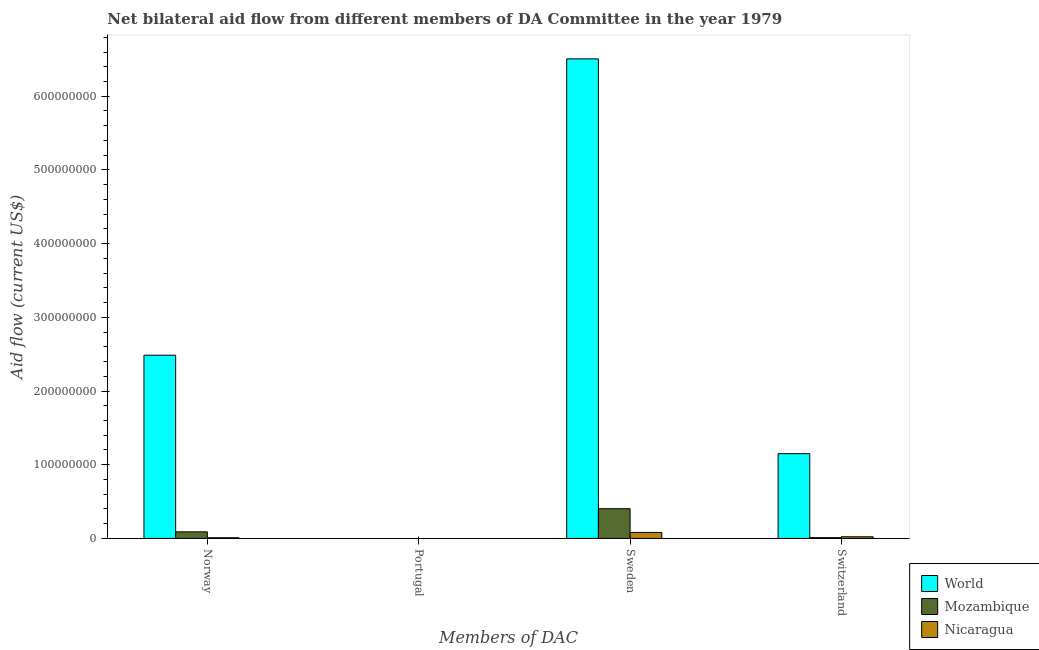How many bars are there on the 3rd tick from the right?
Give a very brief answer. 0. What is the label of the 2nd group of bars from the left?
Offer a very short reply. Portugal. What is the amount of aid given by norway in Nicaragua?
Your answer should be very brief. 9.30e+05. Across all countries, what is the maximum amount of aid given by sweden?
Your answer should be compact. 6.51e+08. Across all countries, what is the minimum amount of aid given by norway?
Offer a terse response. 9.30e+05. What is the total amount of aid given by norway in the graph?
Ensure brevity in your answer.  2.59e+08. What is the difference between the amount of aid given by sweden in World and that in Nicaragua?
Give a very brief answer. 6.43e+08. What is the difference between the amount of aid given by sweden in World and the amount of aid given by norway in Mozambique?
Make the answer very short. 6.42e+08. What is the average amount of aid given by switzerland per country?
Your answer should be compact. 3.95e+07. What is the difference between the amount of aid given by norway and amount of aid given by switzerland in Nicaragua?
Your answer should be compact. -1.34e+06. What is the ratio of the amount of aid given by sweden in Mozambique to that in Nicaragua?
Ensure brevity in your answer.  4.97. Is the difference between the amount of aid given by norway in World and Mozambique greater than the difference between the amount of aid given by sweden in World and Mozambique?
Provide a short and direct response. No. What is the difference between the highest and the second highest amount of aid given by norway?
Offer a terse response. 2.40e+08. What is the difference between the highest and the lowest amount of aid given by sweden?
Offer a terse response. 6.43e+08. In how many countries, is the amount of aid given by sweden greater than the average amount of aid given by sweden taken over all countries?
Your response must be concise. 1. Is it the case that in every country, the sum of the amount of aid given by portugal and amount of aid given by norway is greater than the sum of amount of aid given by switzerland and amount of aid given by sweden?
Ensure brevity in your answer.  No. Is it the case that in every country, the sum of the amount of aid given by norway and amount of aid given by portugal is greater than the amount of aid given by sweden?
Give a very brief answer. No. Are all the bars in the graph horizontal?
Offer a terse response. No. Does the graph contain any zero values?
Your response must be concise. Yes. Where does the legend appear in the graph?
Your response must be concise. Bottom right. What is the title of the graph?
Your answer should be very brief. Net bilateral aid flow from different members of DA Committee in the year 1979. Does "Pakistan" appear as one of the legend labels in the graph?
Offer a very short reply. No. What is the label or title of the X-axis?
Give a very brief answer. Members of DAC. What is the label or title of the Y-axis?
Your answer should be very brief. Aid flow (current US$). What is the Aid flow (current US$) of World in Norway?
Keep it short and to the point. 2.49e+08. What is the Aid flow (current US$) of Mozambique in Norway?
Your response must be concise. 8.96e+06. What is the Aid flow (current US$) in Nicaragua in Norway?
Offer a terse response. 9.30e+05. What is the Aid flow (current US$) in World in Portugal?
Your response must be concise. Nan. What is the Aid flow (current US$) in Mozambique in Portugal?
Provide a short and direct response. Nan. What is the Aid flow (current US$) in Nicaragua in Portugal?
Provide a short and direct response. Nan. What is the Aid flow (current US$) of World in Sweden?
Make the answer very short. 6.51e+08. What is the Aid flow (current US$) of Mozambique in Sweden?
Offer a very short reply. 4.03e+07. What is the Aid flow (current US$) of Nicaragua in Sweden?
Give a very brief answer. 8.12e+06. What is the Aid flow (current US$) of World in Switzerland?
Your response must be concise. 1.15e+08. What is the Aid flow (current US$) of Mozambique in Switzerland?
Your answer should be very brief. 1.09e+06. What is the Aid flow (current US$) of Nicaragua in Switzerland?
Your response must be concise. 2.27e+06. Across all Members of DAC, what is the maximum Aid flow (current US$) of World?
Make the answer very short. 6.51e+08. Across all Members of DAC, what is the maximum Aid flow (current US$) in Mozambique?
Provide a succinct answer. 4.03e+07. Across all Members of DAC, what is the maximum Aid flow (current US$) of Nicaragua?
Give a very brief answer. 8.12e+06. Across all Members of DAC, what is the minimum Aid flow (current US$) in World?
Your response must be concise. 1.15e+08. Across all Members of DAC, what is the minimum Aid flow (current US$) of Mozambique?
Your answer should be very brief. 1.09e+06. Across all Members of DAC, what is the minimum Aid flow (current US$) in Nicaragua?
Your answer should be compact. 9.30e+05. What is the total Aid flow (current US$) in World in the graph?
Provide a succinct answer. 1.01e+09. What is the total Aid flow (current US$) of Mozambique in the graph?
Offer a terse response. 5.04e+07. What is the total Aid flow (current US$) of Nicaragua in the graph?
Offer a very short reply. 1.13e+07. What is the difference between the Aid flow (current US$) in World in Norway and that in Portugal?
Provide a short and direct response. Nan. What is the difference between the Aid flow (current US$) in Mozambique in Norway and that in Portugal?
Provide a succinct answer. Nan. What is the difference between the Aid flow (current US$) in Nicaragua in Norway and that in Portugal?
Your answer should be very brief. Nan. What is the difference between the Aid flow (current US$) of World in Norway and that in Sweden?
Offer a very short reply. -4.02e+08. What is the difference between the Aid flow (current US$) in Mozambique in Norway and that in Sweden?
Keep it short and to the point. -3.14e+07. What is the difference between the Aid flow (current US$) of Nicaragua in Norway and that in Sweden?
Keep it short and to the point. -7.19e+06. What is the difference between the Aid flow (current US$) in World in Norway and that in Switzerland?
Offer a very short reply. 1.34e+08. What is the difference between the Aid flow (current US$) in Mozambique in Norway and that in Switzerland?
Provide a succinct answer. 7.87e+06. What is the difference between the Aid flow (current US$) of Nicaragua in Norway and that in Switzerland?
Your answer should be very brief. -1.34e+06. What is the difference between the Aid flow (current US$) of World in Portugal and that in Sweden?
Your response must be concise. Nan. What is the difference between the Aid flow (current US$) of Mozambique in Portugal and that in Sweden?
Keep it short and to the point. Nan. What is the difference between the Aid flow (current US$) of Nicaragua in Portugal and that in Sweden?
Offer a very short reply. Nan. What is the difference between the Aid flow (current US$) of World in Portugal and that in Switzerland?
Give a very brief answer. Nan. What is the difference between the Aid flow (current US$) in Mozambique in Portugal and that in Switzerland?
Make the answer very short. Nan. What is the difference between the Aid flow (current US$) of Nicaragua in Portugal and that in Switzerland?
Give a very brief answer. Nan. What is the difference between the Aid flow (current US$) in World in Sweden and that in Switzerland?
Your answer should be very brief. 5.36e+08. What is the difference between the Aid flow (current US$) of Mozambique in Sweden and that in Switzerland?
Provide a short and direct response. 3.92e+07. What is the difference between the Aid flow (current US$) in Nicaragua in Sweden and that in Switzerland?
Provide a succinct answer. 5.85e+06. What is the difference between the Aid flow (current US$) of World in Norway and the Aid flow (current US$) of Mozambique in Portugal?
Offer a very short reply. Nan. What is the difference between the Aid flow (current US$) in World in Norway and the Aid flow (current US$) in Nicaragua in Portugal?
Offer a very short reply. Nan. What is the difference between the Aid flow (current US$) of Mozambique in Norway and the Aid flow (current US$) of Nicaragua in Portugal?
Your answer should be very brief. Nan. What is the difference between the Aid flow (current US$) in World in Norway and the Aid flow (current US$) in Mozambique in Sweden?
Keep it short and to the point. 2.08e+08. What is the difference between the Aid flow (current US$) of World in Norway and the Aid flow (current US$) of Nicaragua in Sweden?
Offer a terse response. 2.41e+08. What is the difference between the Aid flow (current US$) in Mozambique in Norway and the Aid flow (current US$) in Nicaragua in Sweden?
Ensure brevity in your answer.  8.40e+05. What is the difference between the Aid flow (current US$) of World in Norway and the Aid flow (current US$) of Mozambique in Switzerland?
Keep it short and to the point. 2.48e+08. What is the difference between the Aid flow (current US$) of World in Norway and the Aid flow (current US$) of Nicaragua in Switzerland?
Provide a short and direct response. 2.46e+08. What is the difference between the Aid flow (current US$) in Mozambique in Norway and the Aid flow (current US$) in Nicaragua in Switzerland?
Provide a short and direct response. 6.69e+06. What is the difference between the Aid flow (current US$) in World in Portugal and the Aid flow (current US$) in Mozambique in Sweden?
Your answer should be very brief. Nan. What is the difference between the Aid flow (current US$) of World in Portugal and the Aid flow (current US$) of Nicaragua in Sweden?
Keep it short and to the point. Nan. What is the difference between the Aid flow (current US$) in Mozambique in Portugal and the Aid flow (current US$) in Nicaragua in Sweden?
Make the answer very short. Nan. What is the difference between the Aid flow (current US$) in World in Portugal and the Aid flow (current US$) in Mozambique in Switzerland?
Offer a terse response. Nan. What is the difference between the Aid flow (current US$) of World in Portugal and the Aid flow (current US$) of Nicaragua in Switzerland?
Offer a terse response. Nan. What is the difference between the Aid flow (current US$) in Mozambique in Portugal and the Aid flow (current US$) in Nicaragua in Switzerland?
Your answer should be compact. Nan. What is the difference between the Aid flow (current US$) in World in Sweden and the Aid flow (current US$) in Mozambique in Switzerland?
Keep it short and to the point. 6.50e+08. What is the difference between the Aid flow (current US$) of World in Sweden and the Aid flow (current US$) of Nicaragua in Switzerland?
Provide a succinct answer. 6.48e+08. What is the difference between the Aid flow (current US$) of Mozambique in Sweden and the Aid flow (current US$) of Nicaragua in Switzerland?
Ensure brevity in your answer.  3.81e+07. What is the average Aid flow (current US$) in World per Members of DAC?
Provide a short and direct response. 2.54e+08. What is the average Aid flow (current US$) of Mozambique per Members of DAC?
Your answer should be very brief. 1.26e+07. What is the average Aid flow (current US$) of Nicaragua per Members of DAC?
Ensure brevity in your answer.  2.83e+06. What is the difference between the Aid flow (current US$) of World and Aid flow (current US$) of Mozambique in Norway?
Give a very brief answer. 2.40e+08. What is the difference between the Aid flow (current US$) of World and Aid flow (current US$) of Nicaragua in Norway?
Offer a very short reply. 2.48e+08. What is the difference between the Aid flow (current US$) of Mozambique and Aid flow (current US$) of Nicaragua in Norway?
Offer a very short reply. 8.03e+06. What is the difference between the Aid flow (current US$) in World and Aid flow (current US$) in Mozambique in Portugal?
Provide a succinct answer. Nan. What is the difference between the Aid flow (current US$) in World and Aid flow (current US$) in Nicaragua in Portugal?
Offer a terse response. Nan. What is the difference between the Aid flow (current US$) of Mozambique and Aid flow (current US$) of Nicaragua in Portugal?
Give a very brief answer. Nan. What is the difference between the Aid flow (current US$) in World and Aid flow (current US$) in Mozambique in Sweden?
Offer a terse response. 6.10e+08. What is the difference between the Aid flow (current US$) in World and Aid flow (current US$) in Nicaragua in Sweden?
Offer a very short reply. 6.43e+08. What is the difference between the Aid flow (current US$) of Mozambique and Aid flow (current US$) of Nicaragua in Sweden?
Your answer should be very brief. 3.22e+07. What is the difference between the Aid flow (current US$) in World and Aid flow (current US$) in Mozambique in Switzerland?
Make the answer very short. 1.14e+08. What is the difference between the Aid flow (current US$) of World and Aid flow (current US$) of Nicaragua in Switzerland?
Provide a short and direct response. 1.13e+08. What is the difference between the Aid flow (current US$) in Mozambique and Aid flow (current US$) in Nicaragua in Switzerland?
Provide a short and direct response. -1.18e+06. What is the ratio of the Aid flow (current US$) in World in Norway to that in Portugal?
Ensure brevity in your answer.  Nan. What is the ratio of the Aid flow (current US$) in Mozambique in Norway to that in Portugal?
Provide a succinct answer. Nan. What is the ratio of the Aid flow (current US$) in Nicaragua in Norway to that in Portugal?
Offer a terse response. Nan. What is the ratio of the Aid flow (current US$) in World in Norway to that in Sweden?
Ensure brevity in your answer.  0.38. What is the ratio of the Aid flow (current US$) in Mozambique in Norway to that in Sweden?
Your response must be concise. 0.22. What is the ratio of the Aid flow (current US$) of Nicaragua in Norway to that in Sweden?
Provide a short and direct response. 0.11. What is the ratio of the Aid flow (current US$) of World in Norway to that in Switzerland?
Offer a terse response. 2.16. What is the ratio of the Aid flow (current US$) in Mozambique in Norway to that in Switzerland?
Your answer should be compact. 8.22. What is the ratio of the Aid flow (current US$) in Nicaragua in Norway to that in Switzerland?
Keep it short and to the point. 0.41. What is the ratio of the Aid flow (current US$) of World in Portugal to that in Sweden?
Ensure brevity in your answer.  Nan. What is the ratio of the Aid flow (current US$) of Mozambique in Portugal to that in Sweden?
Your answer should be very brief. Nan. What is the ratio of the Aid flow (current US$) in Nicaragua in Portugal to that in Sweden?
Offer a terse response. Nan. What is the ratio of the Aid flow (current US$) of World in Portugal to that in Switzerland?
Give a very brief answer. Nan. What is the ratio of the Aid flow (current US$) in Mozambique in Portugal to that in Switzerland?
Keep it short and to the point. Nan. What is the ratio of the Aid flow (current US$) in Nicaragua in Portugal to that in Switzerland?
Keep it short and to the point. Nan. What is the ratio of the Aid flow (current US$) in World in Sweden to that in Switzerland?
Offer a terse response. 5.66. What is the ratio of the Aid flow (current US$) in Nicaragua in Sweden to that in Switzerland?
Provide a succinct answer. 3.58. What is the difference between the highest and the second highest Aid flow (current US$) of World?
Your answer should be compact. 4.02e+08. What is the difference between the highest and the second highest Aid flow (current US$) in Mozambique?
Ensure brevity in your answer.  3.14e+07. What is the difference between the highest and the second highest Aid flow (current US$) in Nicaragua?
Offer a very short reply. 5.85e+06. What is the difference between the highest and the lowest Aid flow (current US$) in World?
Make the answer very short. 5.36e+08. What is the difference between the highest and the lowest Aid flow (current US$) in Mozambique?
Your response must be concise. 3.92e+07. What is the difference between the highest and the lowest Aid flow (current US$) of Nicaragua?
Offer a terse response. 7.19e+06. 